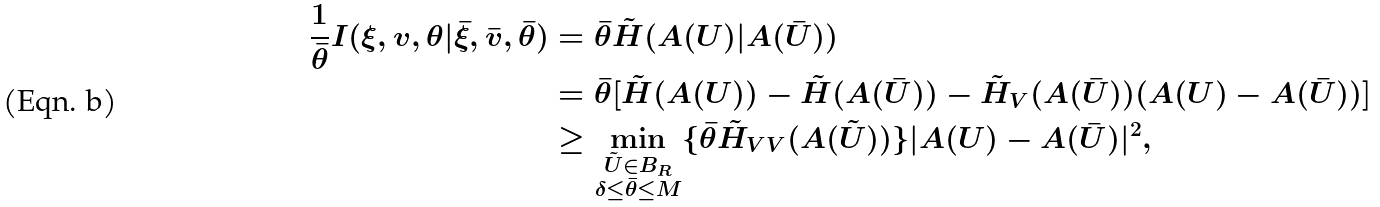<formula> <loc_0><loc_0><loc_500><loc_500>\frac { 1 } { \bar { \theta } } I ( \xi , v , \theta | \bar { \xi } , \bar { v } , \bar { \theta } ) & = \bar { \theta } \tilde { H } ( A ( U ) | A ( \bar { U } ) ) \\ & = \bar { \theta } [ \tilde { H } ( A ( U ) ) - \tilde { H } ( A ( \bar { U } ) ) - \tilde { H } _ { V } ( A ( \bar { U } ) ) ( A ( U ) - A ( \bar { U } ) ) ] \\ & \geq \min _ { \substack { \tilde { U } \in B _ { R } \\ \delta \leq \bar { \theta } \leq M } } \{ \bar { \theta } \tilde { H } _ { V V } ( A ( \tilde { U } ) ) \} | A ( U ) - A ( \bar { U } ) | ^ { 2 } ,</formula> 